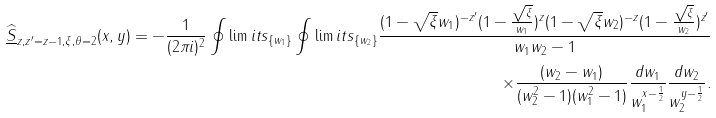<formula> <loc_0><loc_0><loc_500><loc_500>\widehat { \underline { S } } _ { z , z ^ { \prime } = z - 1 , \xi , \theta = 2 } ( x , y ) = - \frac { 1 } { ( 2 \pi i ) ^ { 2 } } \oint \lim i t s _ { \{ w _ { 1 } \} } \oint \lim i t s _ { \{ w _ { 2 } \} } \frac { ( 1 - \sqrt { \xi } w _ { 1 } ) ^ { - z ^ { \prime } } ( 1 - \frac { \sqrt { \xi } } { w _ { 1 } } ) ^ { z } ( 1 - \sqrt { \xi } w _ { 2 } ) ^ { - z } ( 1 - \frac { \sqrt { \xi } } { w _ { 2 } } ) ^ { z ^ { \prime } } } { w _ { 1 } w _ { 2 } - 1 } \\ \times \frac { ( w _ { 2 } - w _ { 1 } ) } { ( w _ { 2 } ^ { 2 } - 1 ) ( w _ { 1 } ^ { 2 } - 1 ) } \frac { d w _ { 1 } } { w _ { 1 } ^ { x - \frac { 1 } { 2 } } } \frac { d w _ { 2 } } { w _ { 2 } ^ { y - \frac { 1 } { 2 } } } .</formula> 